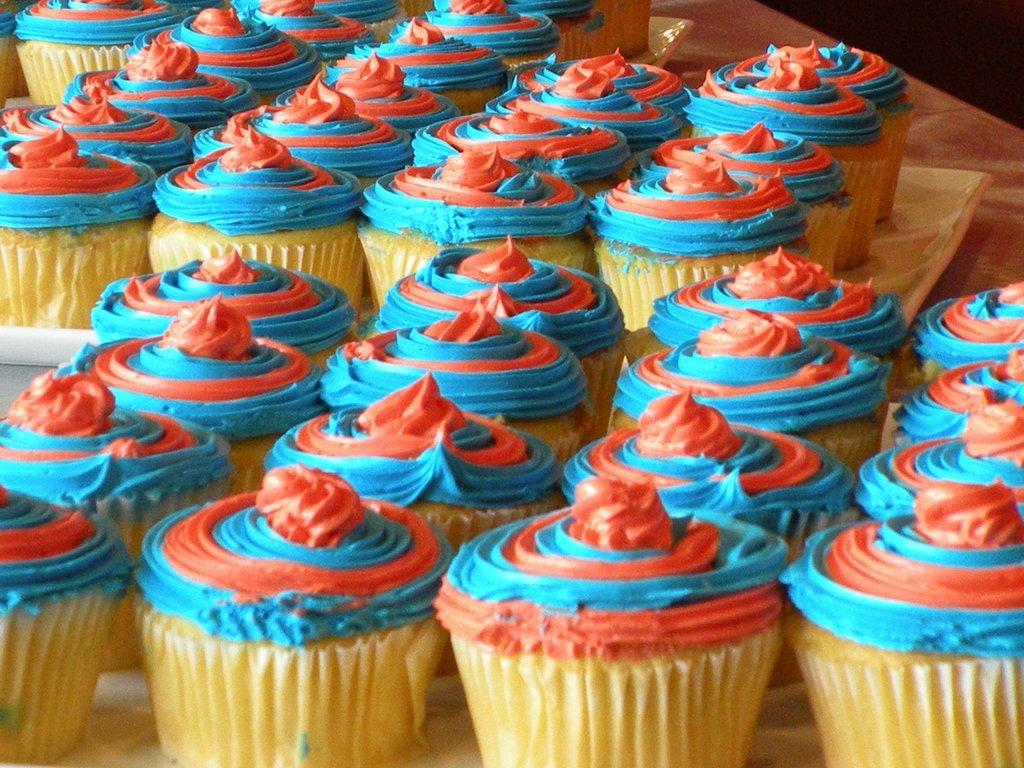What type of food can be seen in the image? There are cupcakes in the image. What is the tray used for in the image? The tray is used to hold the cupcakes in the image. Where is the tray located in the image? The tray is placed on a table in the image. What type of rock can be seen in the image? There is no rock present in the image; it features cupcakes on a tray placed on a table. 